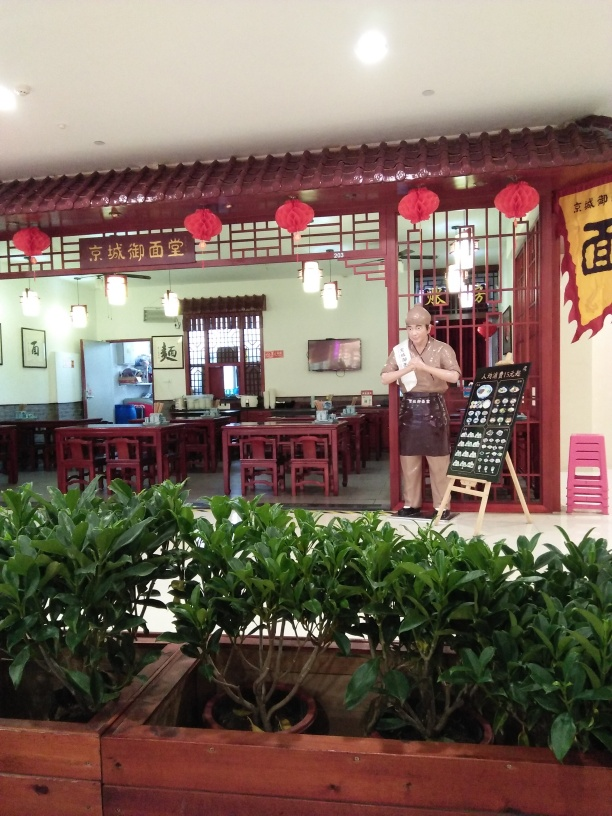Is the overall quality of the image good?
A. Yes
B. No
Answer with the option's letter from the given choices directly.
 A. 